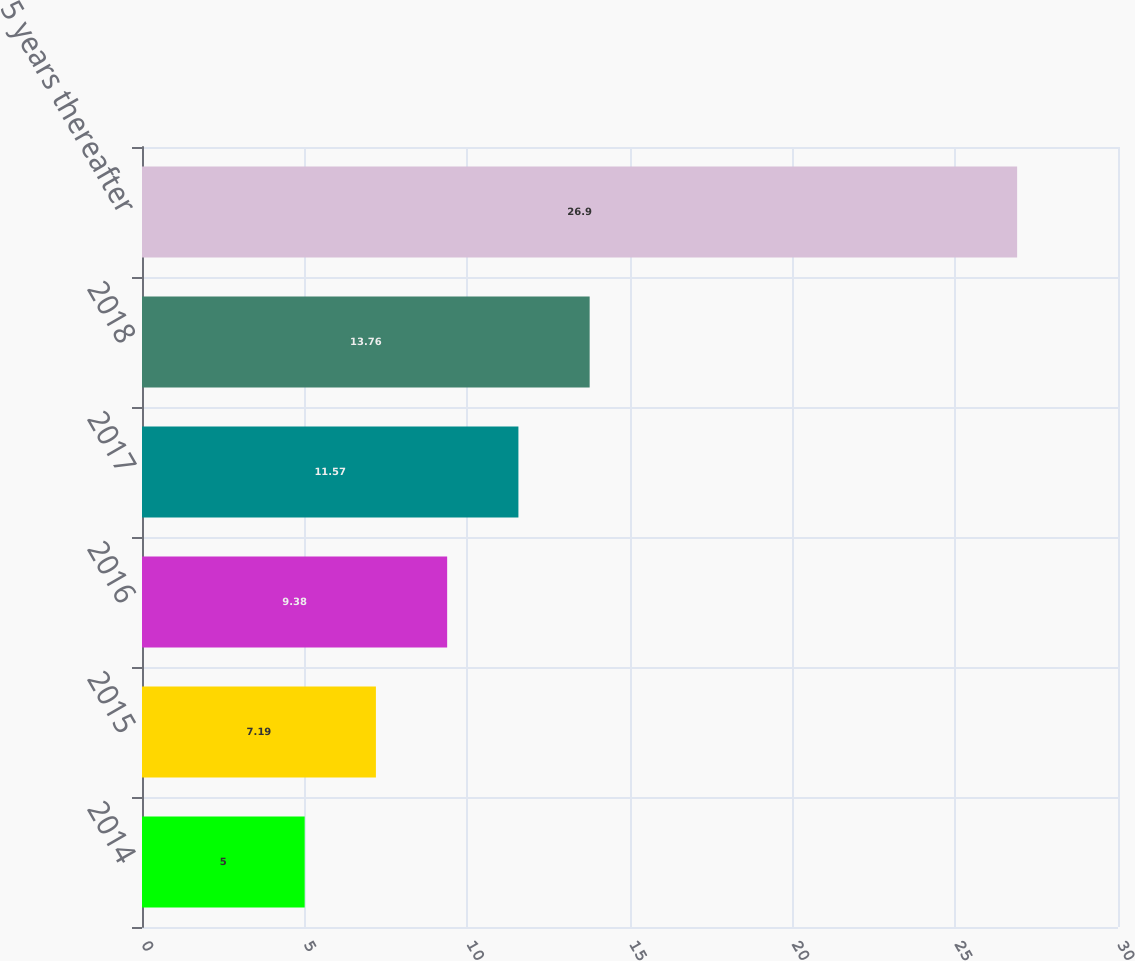Convert chart to OTSL. <chart><loc_0><loc_0><loc_500><loc_500><bar_chart><fcel>2014<fcel>2015<fcel>2016<fcel>2017<fcel>2018<fcel>5 years thereafter<nl><fcel>5<fcel>7.19<fcel>9.38<fcel>11.57<fcel>13.76<fcel>26.9<nl></chart> 